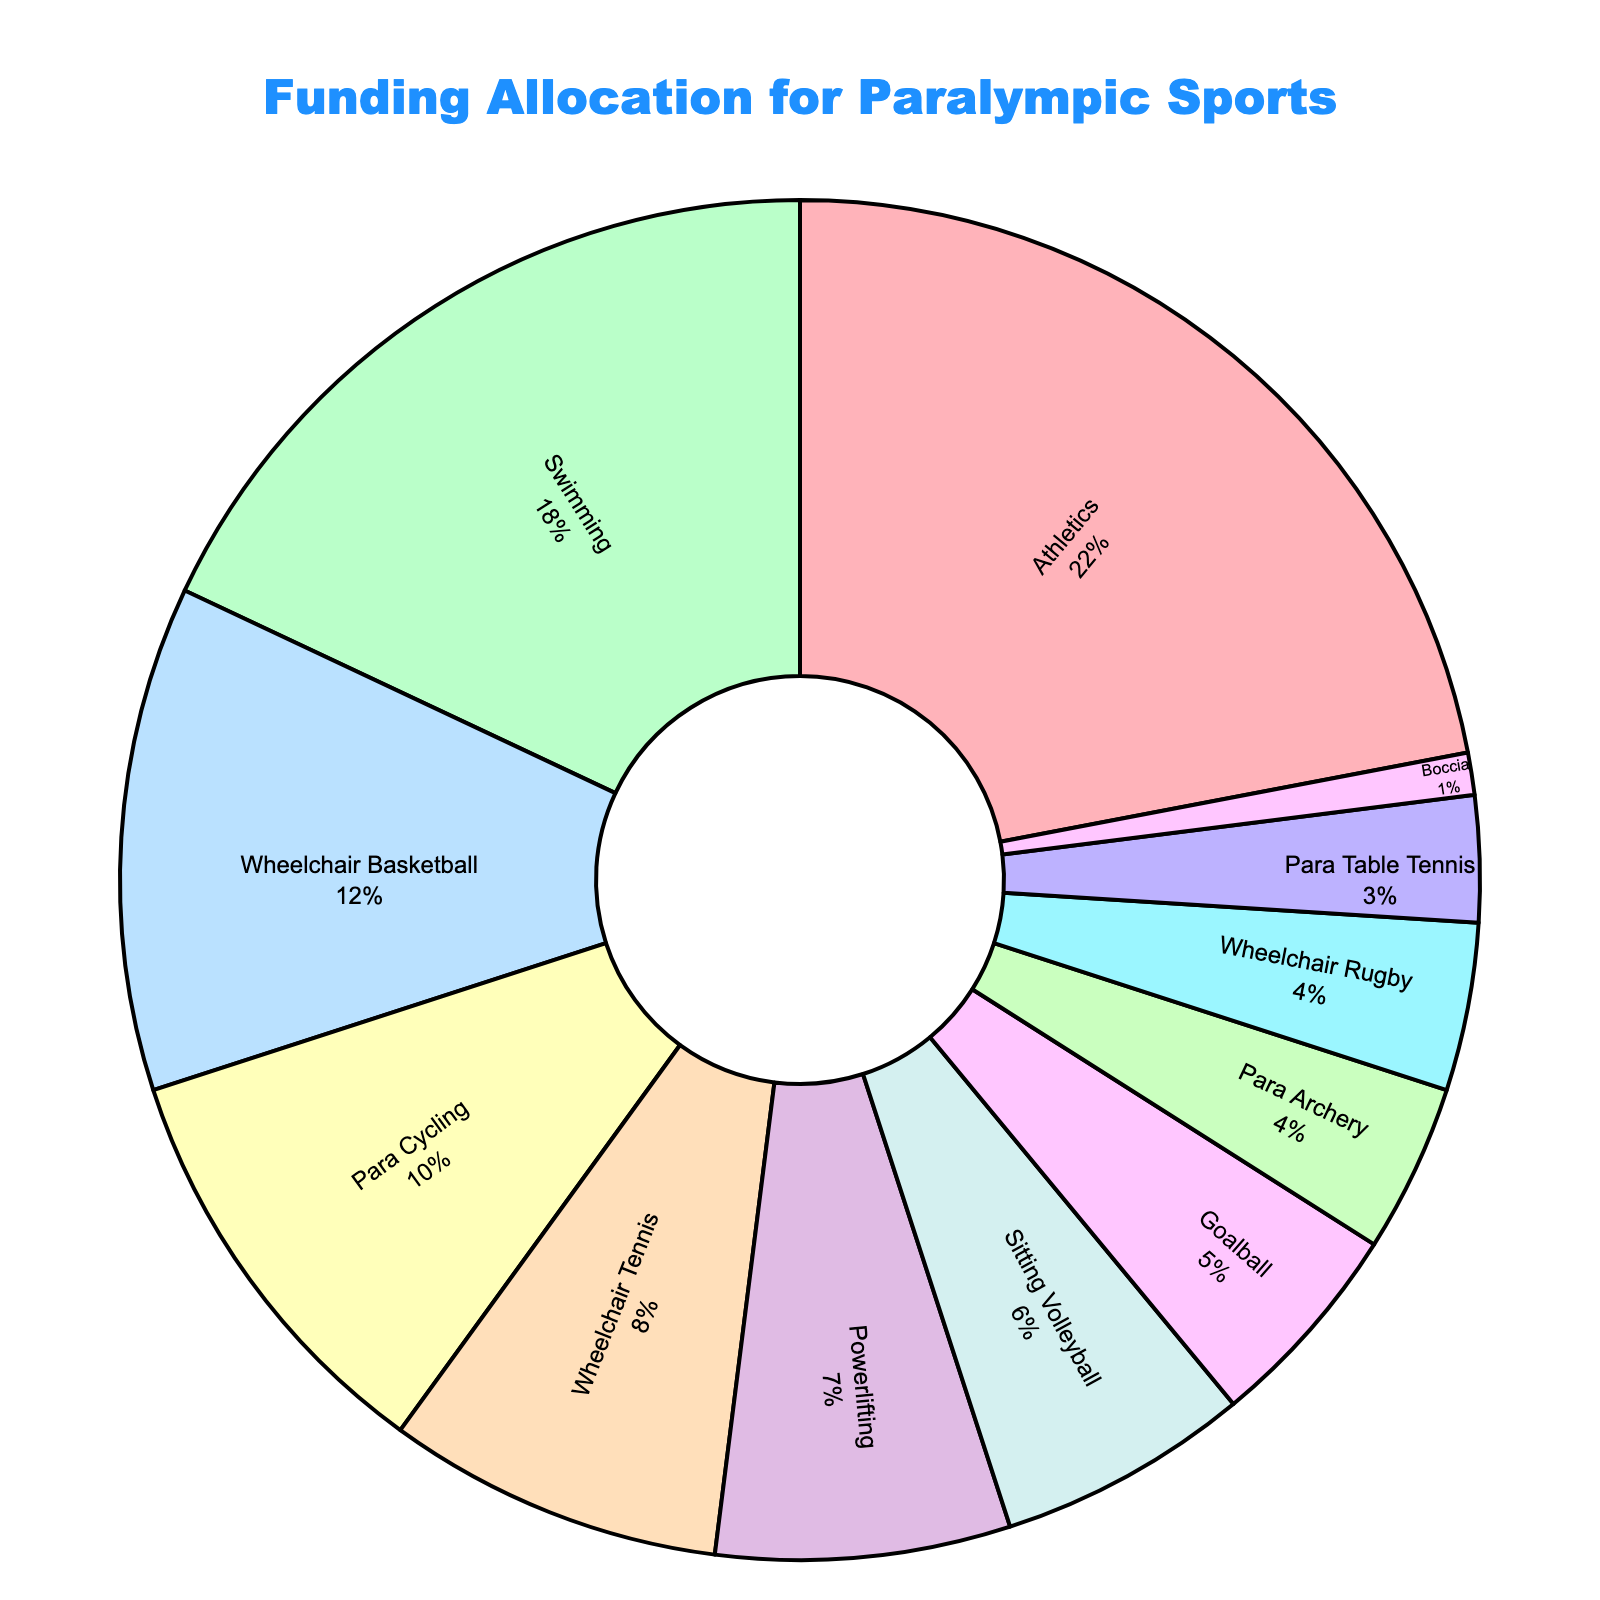Which sport receives the highest funding allocation? The pie chart shows the percentage of funding allocations. Athletics has the largest slice, indicating it receives the highest funding allocation.
Answer: Athletics What is the combined funding allocation for Wheelchair Basketball and Para Cycling? Sum the funding percentages for Wheelchair Basketball (12%) and Para Cycling (10%). 12% + 10% = 22%
Answer: 22% How much more funding does Swimming receive compared to Wheelchair Rugby? Subtract the percentage for Wheelchair Rugby (4%) from the percentage for Swimming (18%). 18% - 4% = 14%
Answer: 14% Which sport receives the least amount of funding? The smallest slice in the pie chart represents the sport with the least funding, which is Boccia at 1%.
Answer: Boccia Is the funding allocation for Powerlifting greater than that for Para Table Tennis and Boccia combined? Sum the percentages for Para Table Tennis (3%) and Boccia (1%). 3% + 1% = 4%. Since Powerlifting receives 7%, it is indeed greater.
Answer: Yes How does the funding allocation for Goalball compare to Sitting Volleyball? Goalball gets 5% of the funding, while Sitting Volleyball gets 6%. Therefore, Goalball receives 1% less than Sitting Volleyball.
Answer: 1% less What percentage of the total funding is allocated to sports other than Athletics? Athletics receives 22%, so the remaining percentage is 100% - 22%. 100% - 22% = 78%
Answer: 78% Is the funding allocation for Athletics plus Swimming greater than half of the total funding allocation? Add the percentages for Athletics (22%) and Swimming (18%): 22% + 18% = 40%. Since 40% is less than 50%, it's not greater than half.
Answer: No What is the difference in funding allocation between Para Archery and Wheelchair Tennis? Subtract the percentage for Para Archery (4%) from the percentage for Wheelchair Tennis (8%). 8% - 4% = 4%
Answer: 4% Among the top three sports receiving the highest funding allocations, what is the average percentage? The top three sports are Athletics (22%), Swimming (18%), and Wheelchair Basketball (12%). Their average is (22% + 18% + 12%) / 3 = 52% / 3 ≈ 17.33%
Answer: 17.33% 